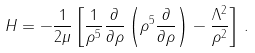Convert formula to latex. <formula><loc_0><loc_0><loc_500><loc_500>H = - \frac { 1 } { 2 \mu } \left [ \frac { 1 } { \rho ^ { 5 } } \frac { \partial } { \partial \rho } \left ( \rho ^ { 5 } \frac { \partial } { \partial \rho } \right ) - \frac { \Lambda ^ { 2 } } { \rho ^ { 2 } } \right ] \, .</formula> 